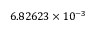<formula> <loc_0><loc_0><loc_500><loc_500>6 . 8 2 6 2 3 \times 1 0 ^ { - 3 }</formula> 